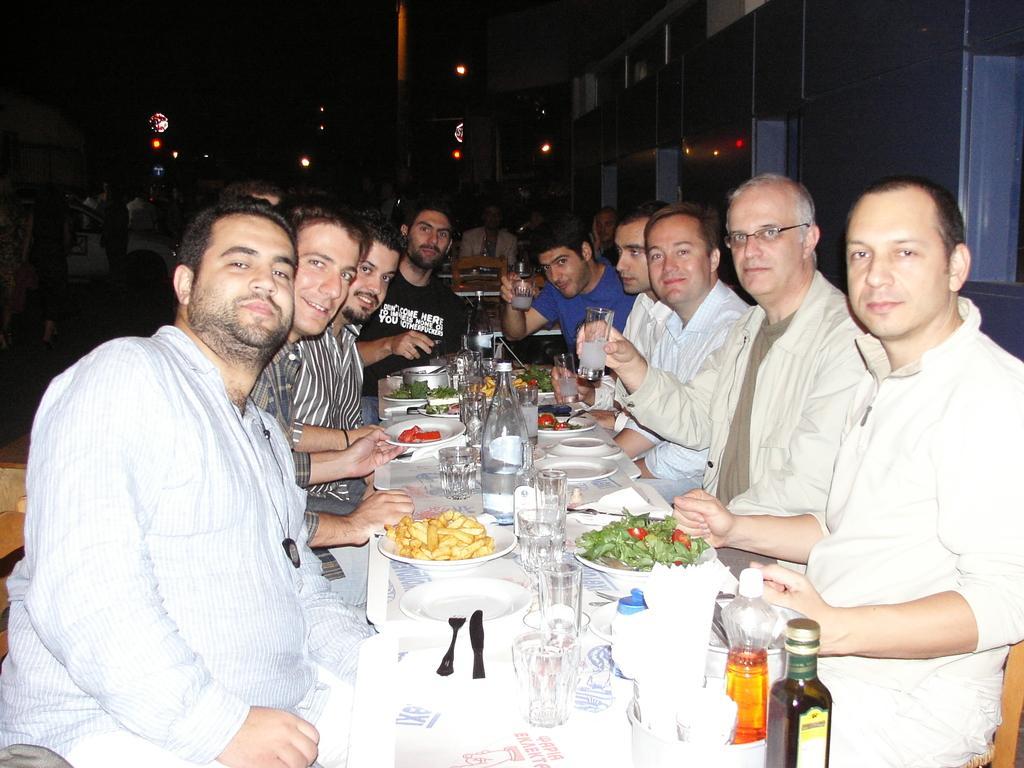How would you summarize this image in a sentence or two? At the bottom of the picture, we see a table on which the plates, spoons, forks, glasses, glass bottles, water bottles, plates containing the food, bowls and some other objects are placed. On either side of the table, we see the men are sitting on the chairs. Behind them, we see the people are sitting on the chairs. In front of them, we see a table. On the left side, we see a white vehicle. Beside that, we see the people are standing. On the right side, we see a wall in grey color. In the background, we see the lights and a pole. At the top, it is black in color. 